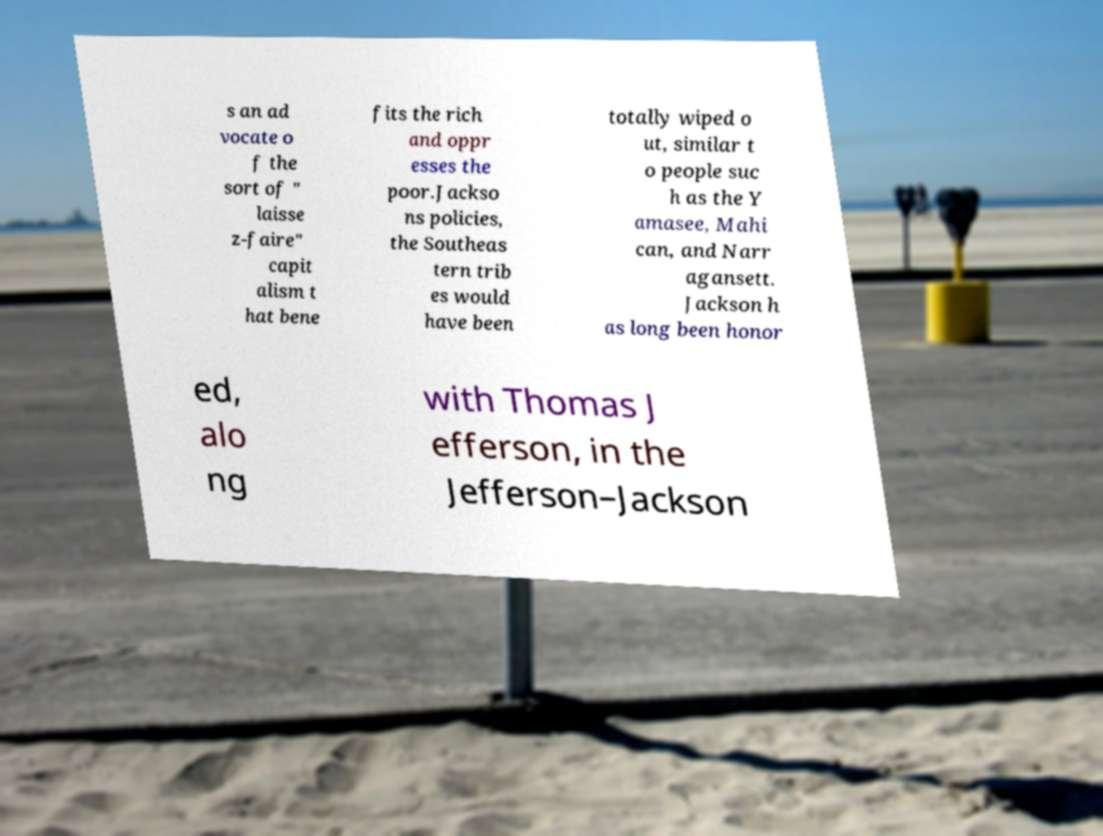What messages or text are displayed in this image? I need them in a readable, typed format. s an ad vocate o f the sort of " laisse z-faire" capit alism t hat bene fits the rich and oppr esses the poor.Jackso ns policies, the Southeas tern trib es would have been totally wiped o ut, similar t o people suc h as the Y amasee, Mahi can, and Narr agansett. Jackson h as long been honor ed, alo ng with Thomas J efferson, in the Jefferson–Jackson 